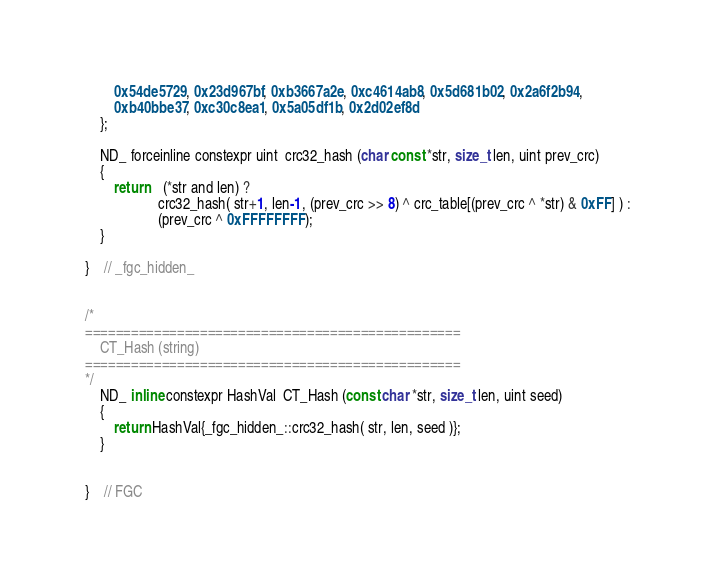<code> <loc_0><loc_0><loc_500><loc_500><_C_>		0x54de5729, 0x23d967bf, 0xb3667a2e, 0xc4614ab8, 0x5d681b02, 0x2a6f2b94,
		0xb40bbe37, 0xc30c8ea1, 0x5a05df1b, 0x2d02ef8d
	};

	ND_ forceinline constexpr uint  crc32_hash (char const *str, size_t len, uint prev_crc)
	{
		return	(*str and len) ?
					crc32_hash( str+1, len-1, (prev_crc >> 8) ^ crc_table[(prev_crc ^ *str) & 0xFF] ) :
					(prev_crc ^ 0xFFFFFFFF);
	}

}	// _fgc_hidden_


/*
=================================================
	CT_Hash (string)
=================================================
*/
	ND_ inline constexpr HashVal  CT_Hash (const char *str, size_t len, uint seed)
	{
		return HashVal{_fgc_hidden_::crc32_hash( str, len, seed )};
	}


}	// FGC
</code> 